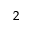Convert formula to latex. <formula><loc_0><loc_0><loc_500><loc_500>^ { 2 }</formula> 